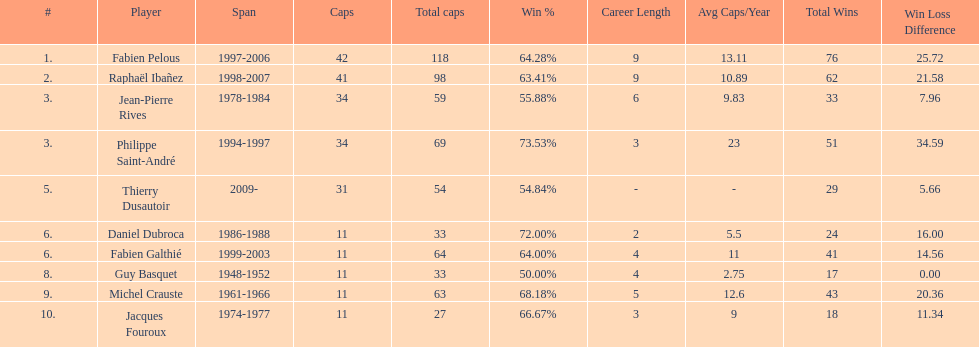How many caps did jean-pierre rives and michel crauste accrue? 122. 